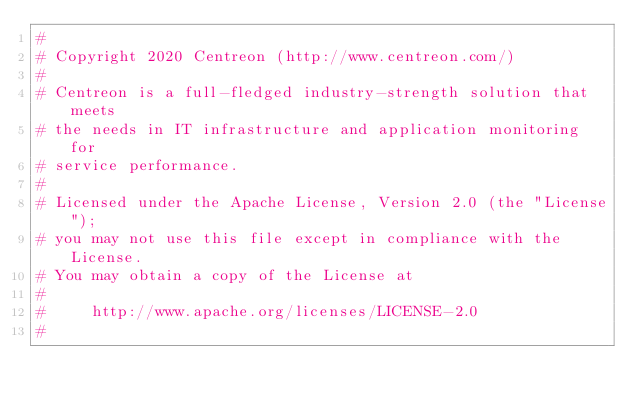Convert code to text. <code><loc_0><loc_0><loc_500><loc_500><_Perl_>#
# Copyright 2020 Centreon (http://www.centreon.com/)
#
# Centreon is a full-fledged industry-strength solution that meets
# the needs in IT infrastructure and application monitoring for
# service performance.
#
# Licensed under the Apache License, Version 2.0 (the "License");
# you may not use this file except in compliance with the License.
# You may obtain a copy of the License at
#
#     http://www.apache.org/licenses/LICENSE-2.0
#</code> 